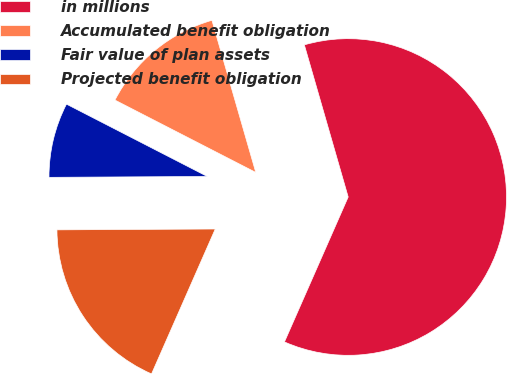<chart> <loc_0><loc_0><loc_500><loc_500><pie_chart><fcel>in millions<fcel>Accumulated benefit obligation<fcel>Fair value of plan assets<fcel>Projected benefit obligation<nl><fcel>61.06%<fcel>12.98%<fcel>7.64%<fcel>18.32%<nl></chart> 